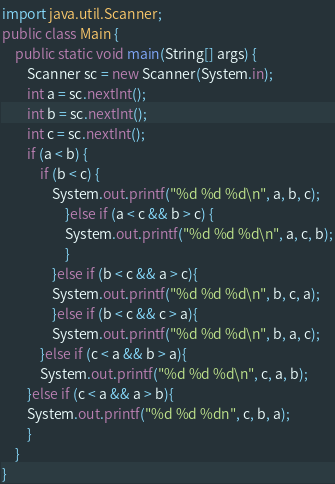<code> <loc_0><loc_0><loc_500><loc_500><_Java_>import java.util.Scanner;
public class Main {
    public static void main(String[] args) {
        Scanner sc = new Scanner(System.in);
        int a = sc.nextInt(); 
        int b = sc.nextInt(); 
        int c = sc.nextInt(); 
        if (a < b) { 
            if (b < c) { 
                System.out.printf("%d %d %d\n", a, b, c);
                    }else if (a < c && b > c) { 
                    System.out.printf("%d %d %d\n", a, c, b);
                    } 
                }else if (b < c && a > c){ 
                System.out.printf("%d %d %d\n", b, c, a);
                }else if (b < c && c > a){
                System.out.printf("%d %d %d\n", b, a, c);
            }else if (c < a && b > a){
            System.out.printf("%d %d %d\n", c, a, b);
        }else if (c < a && a > b){
        System.out.printf("%d %d %dn", c, b, a);
        }
    }
}

</code> 